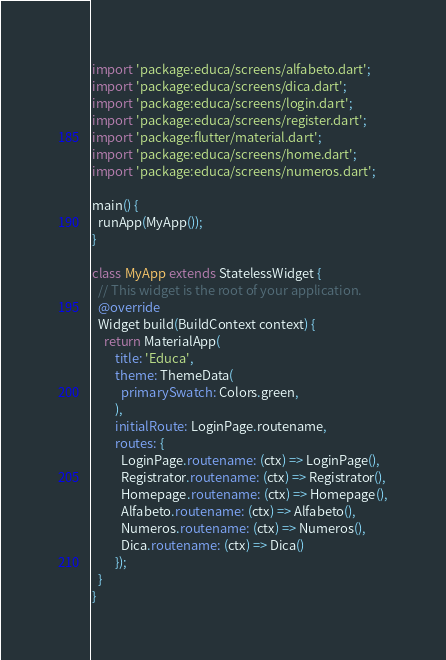<code> <loc_0><loc_0><loc_500><loc_500><_Dart_>import 'package:educa/screens/alfabeto.dart';
import 'package:educa/screens/dica.dart';
import 'package:educa/screens/login.dart';
import 'package:educa/screens/register.dart';
import 'package:flutter/material.dart';
import 'package:educa/screens/home.dart';
import 'package:educa/screens/numeros.dart';

main() {
  runApp(MyApp());
}

class MyApp extends StatelessWidget {
  // This widget is the root of your application.
  @override
  Widget build(BuildContext context) {
    return MaterialApp(
        title: 'Educa',
        theme: ThemeData(
          primarySwatch: Colors.green,
        ),
        initialRoute: LoginPage.routename,
        routes: {
          LoginPage.routename: (ctx) => LoginPage(),
          Registrator.routename: (ctx) => Registrator(),
          Homepage.routename: (ctx) => Homepage(),
          Alfabeto.routename: (ctx) => Alfabeto(),
          Numeros.routename: (ctx) => Numeros(),
          Dica.routename: (ctx) => Dica()
        });
  }
}
</code> 